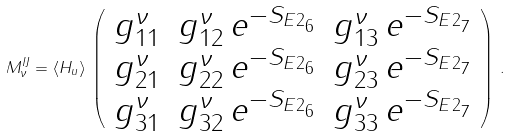Convert formula to latex. <formula><loc_0><loc_0><loc_500><loc_500>M ^ { I J } _ { \nu } = \langle H _ { u } \rangle \, \left ( \begin{array} { c c c } g ^ { \nu } _ { 1 1 } & g ^ { \nu } _ { 1 2 } \, e ^ { - S _ { E 2 _ { 6 } } } & g ^ { \nu } _ { 1 3 } \, e ^ { - S _ { E 2 _ { 7 } } } \\ g ^ { \nu } _ { 2 1 } & g ^ { \nu } _ { 2 2 } \, e ^ { - S _ { E 2 _ { 6 } } } & g ^ { \nu } _ { 2 3 } \, e ^ { - S _ { E 2 _ { 7 } } } \\ g ^ { \nu } _ { 3 1 } & g ^ { \nu } _ { 3 2 } \, e ^ { - S _ { E 2 _ { 6 } } } & g ^ { \nu } _ { 3 3 } \, e ^ { - S _ { E 2 _ { 7 } } } \\ \end{array} \right ) \, .</formula> 